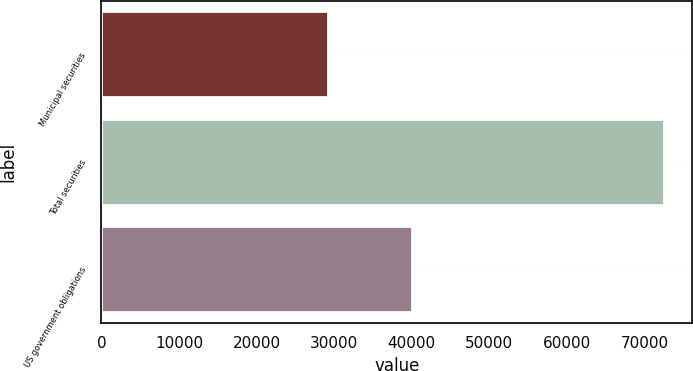Convert chart to OTSL. <chart><loc_0><loc_0><loc_500><loc_500><bar_chart><fcel>Municipal securities<fcel>Total securities<fcel>US government obligations<nl><fcel>29145<fcel>72552<fcel>40078<nl></chart> 